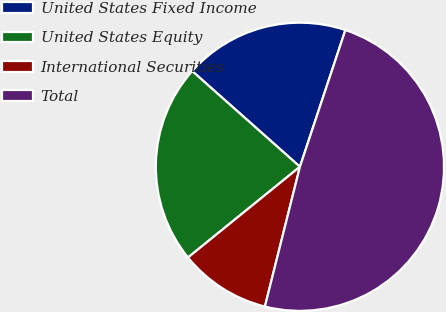Convert chart to OTSL. <chart><loc_0><loc_0><loc_500><loc_500><pie_chart><fcel>United States Fixed Income<fcel>United States Equity<fcel>International Securities<fcel>Total<nl><fcel>18.55%<fcel>22.4%<fcel>10.25%<fcel>48.8%<nl></chart> 